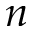Convert formula to latex. <formula><loc_0><loc_0><loc_500><loc_500>n</formula> 